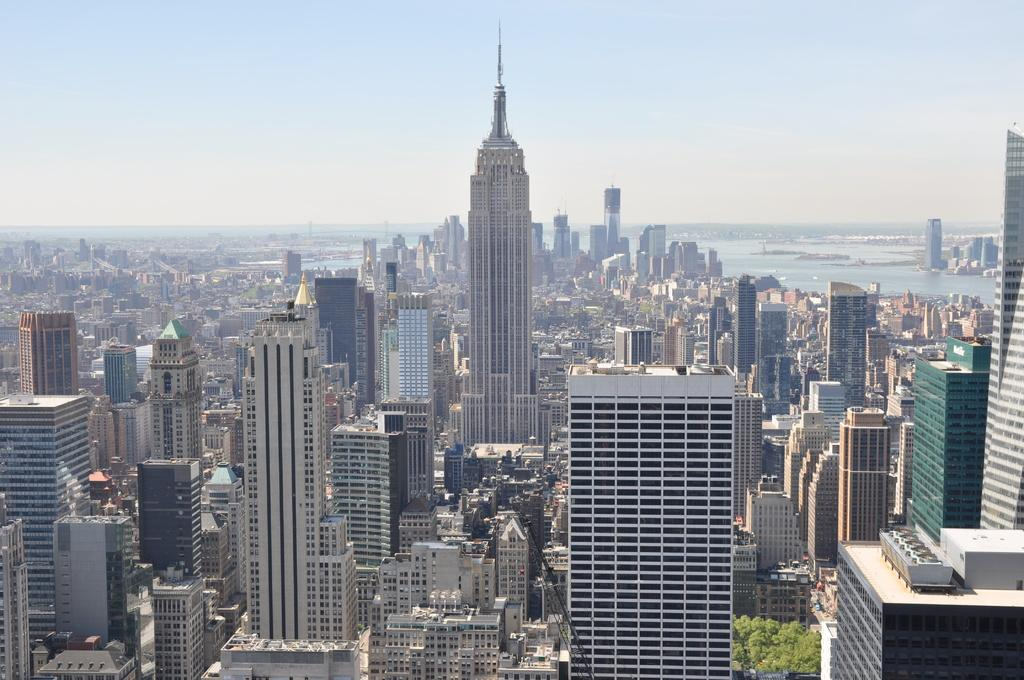What type of view is depicted in the image? The image is an aerial view. What structures can be seen in the image? There are buildings in the image. What type of vegetation is present in the image? There are trees in the image. What natural feature can be seen in the background of the image? There is water visible in the background of the image. What geographical feature is present in the background of the image? There are hills in the background of the image. What is visible at the top of the image? The sky is visible at the top of the image. What type of mint can be seen growing on the hills in the image? There is no mint visible in the image; the geographical feature mentioned is hills, not mint. 